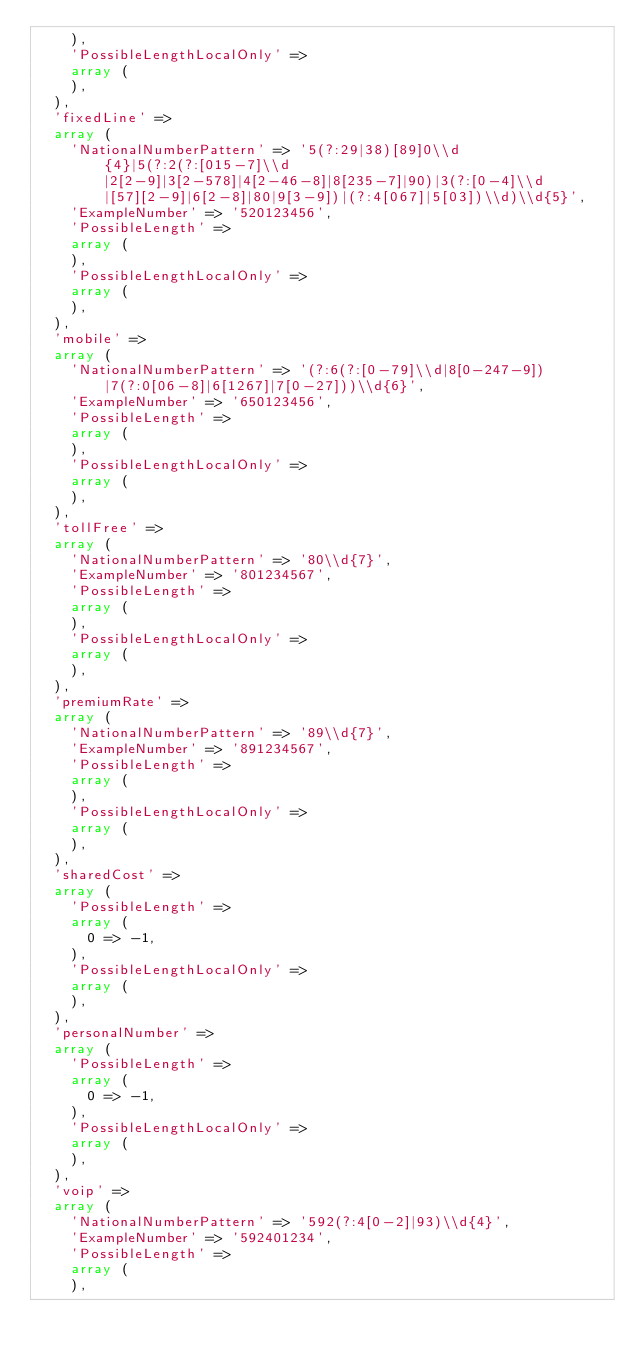<code> <loc_0><loc_0><loc_500><loc_500><_PHP_>    ),
    'PossibleLengthLocalOnly' => 
    array (
    ),
  ),
  'fixedLine' => 
  array (
    'NationalNumberPattern' => '5(?:29|38)[89]0\\d{4}|5(?:2(?:[015-7]\\d|2[2-9]|3[2-578]|4[2-46-8]|8[235-7]|90)|3(?:[0-4]\\d|[57][2-9]|6[2-8]|80|9[3-9])|(?:4[067]|5[03])\\d)\\d{5}',
    'ExampleNumber' => '520123456',
    'PossibleLength' => 
    array (
    ),
    'PossibleLengthLocalOnly' => 
    array (
    ),
  ),
  'mobile' => 
  array (
    'NationalNumberPattern' => '(?:6(?:[0-79]\\d|8[0-247-9])|7(?:0[06-8]|6[1267]|7[0-27]))\\d{6}',
    'ExampleNumber' => '650123456',
    'PossibleLength' => 
    array (
    ),
    'PossibleLengthLocalOnly' => 
    array (
    ),
  ),
  'tollFree' => 
  array (
    'NationalNumberPattern' => '80\\d{7}',
    'ExampleNumber' => '801234567',
    'PossibleLength' => 
    array (
    ),
    'PossibleLengthLocalOnly' => 
    array (
    ),
  ),
  'premiumRate' => 
  array (
    'NationalNumberPattern' => '89\\d{7}',
    'ExampleNumber' => '891234567',
    'PossibleLength' => 
    array (
    ),
    'PossibleLengthLocalOnly' => 
    array (
    ),
  ),
  'sharedCost' => 
  array (
    'PossibleLength' => 
    array (
      0 => -1,
    ),
    'PossibleLengthLocalOnly' => 
    array (
    ),
  ),
  'personalNumber' => 
  array (
    'PossibleLength' => 
    array (
      0 => -1,
    ),
    'PossibleLengthLocalOnly' => 
    array (
    ),
  ),
  'voip' => 
  array (
    'NationalNumberPattern' => '592(?:4[0-2]|93)\\d{4}',
    'ExampleNumber' => '592401234',
    'PossibleLength' => 
    array (
    ),</code> 